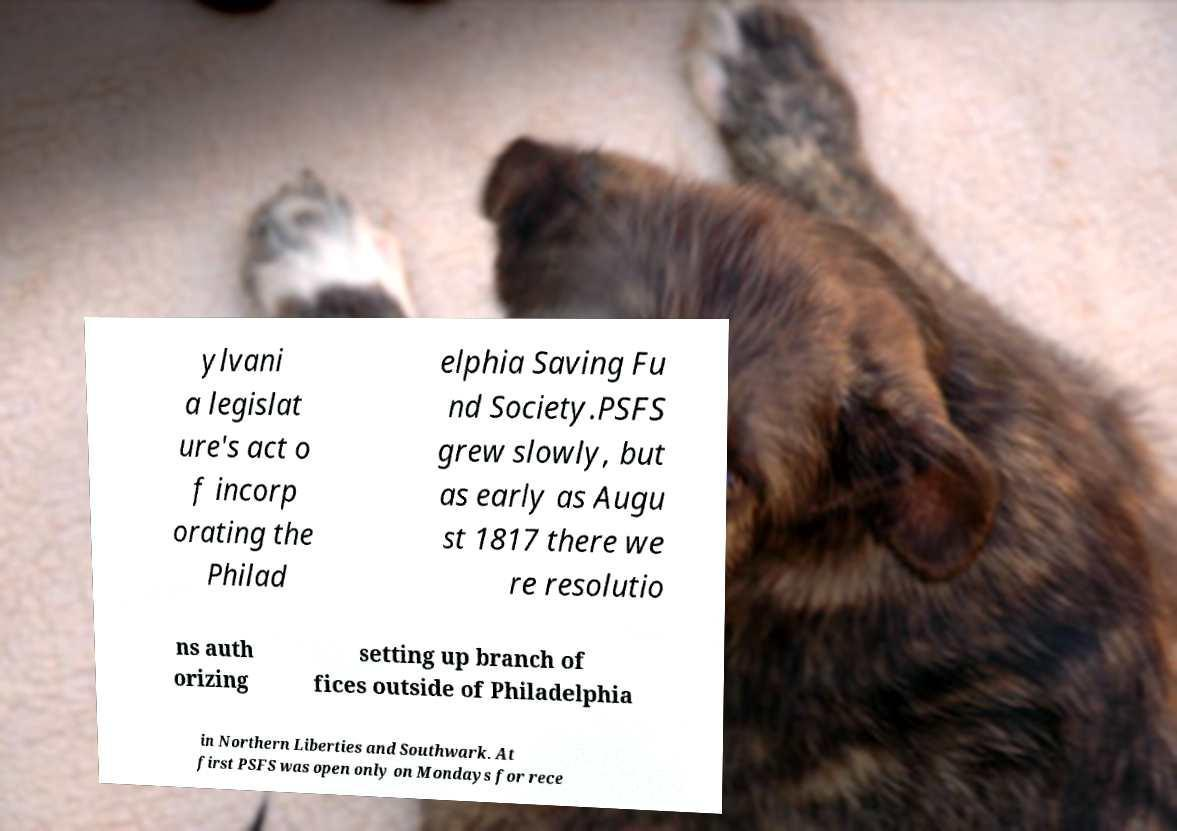Can you read and provide the text displayed in the image?This photo seems to have some interesting text. Can you extract and type it out for me? ylvani a legislat ure's act o f incorp orating the Philad elphia Saving Fu nd Society.PSFS grew slowly, but as early as Augu st 1817 there we re resolutio ns auth orizing setting up branch of fices outside of Philadelphia in Northern Liberties and Southwark. At first PSFS was open only on Mondays for rece 